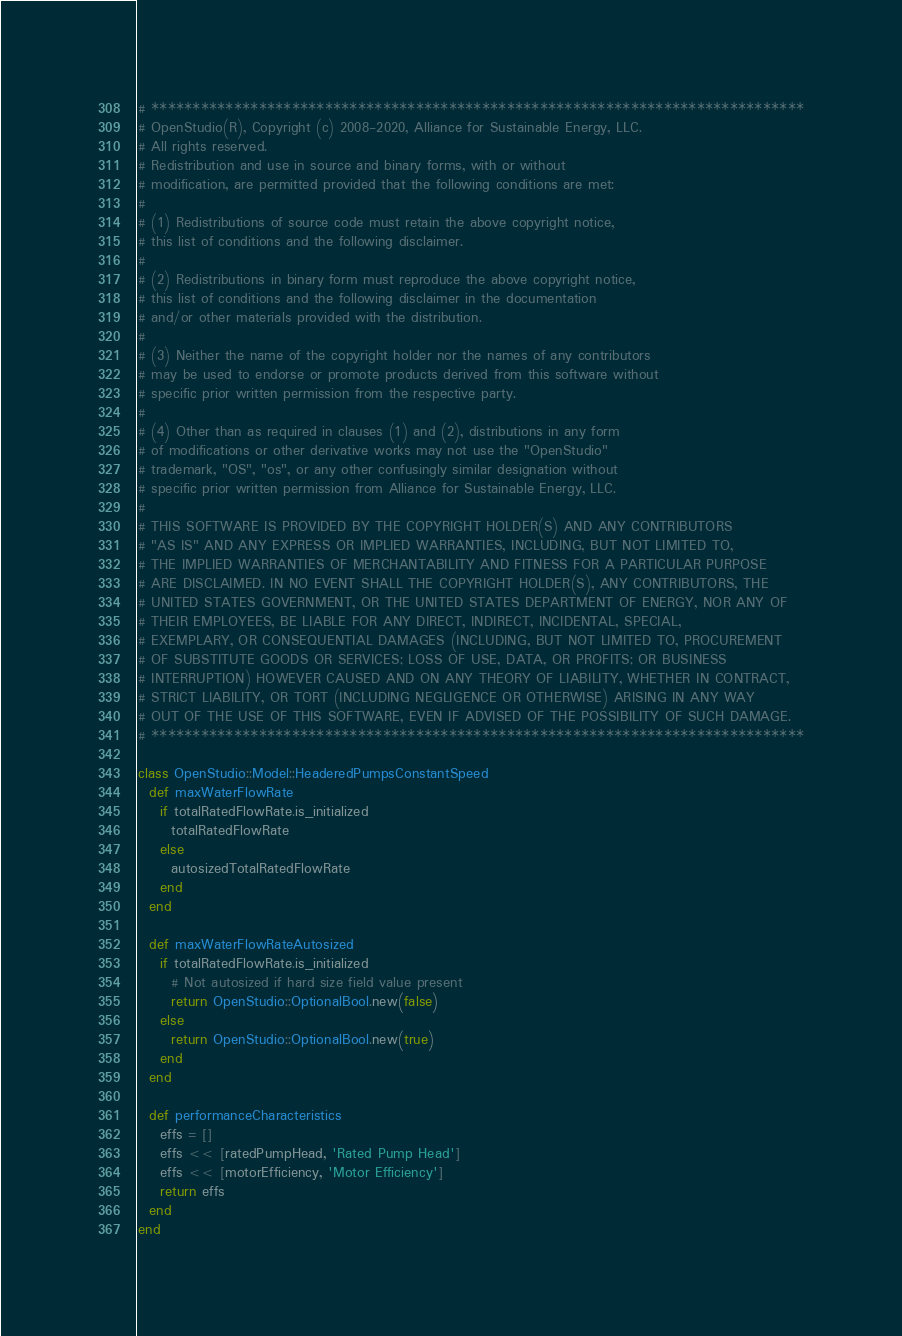<code> <loc_0><loc_0><loc_500><loc_500><_Ruby_># *******************************************************************************
# OpenStudio(R), Copyright (c) 2008-2020, Alliance for Sustainable Energy, LLC.
# All rights reserved.
# Redistribution and use in source and binary forms, with or without
# modification, are permitted provided that the following conditions are met:
#
# (1) Redistributions of source code must retain the above copyright notice,
# this list of conditions and the following disclaimer.
#
# (2) Redistributions in binary form must reproduce the above copyright notice,
# this list of conditions and the following disclaimer in the documentation
# and/or other materials provided with the distribution.
#
# (3) Neither the name of the copyright holder nor the names of any contributors
# may be used to endorse or promote products derived from this software without
# specific prior written permission from the respective party.
#
# (4) Other than as required in clauses (1) and (2), distributions in any form
# of modifications or other derivative works may not use the "OpenStudio"
# trademark, "OS", "os", or any other confusingly similar designation without
# specific prior written permission from Alliance for Sustainable Energy, LLC.
#
# THIS SOFTWARE IS PROVIDED BY THE COPYRIGHT HOLDER(S) AND ANY CONTRIBUTORS
# "AS IS" AND ANY EXPRESS OR IMPLIED WARRANTIES, INCLUDING, BUT NOT LIMITED TO,
# THE IMPLIED WARRANTIES OF MERCHANTABILITY AND FITNESS FOR A PARTICULAR PURPOSE
# ARE DISCLAIMED. IN NO EVENT SHALL THE COPYRIGHT HOLDER(S), ANY CONTRIBUTORS, THE
# UNITED STATES GOVERNMENT, OR THE UNITED STATES DEPARTMENT OF ENERGY, NOR ANY OF
# THEIR EMPLOYEES, BE LIABLE FOR ANY DIRECT, INDIRECT, INCIDENTAL, SPECIAL,
# EXEMPLARY, OR CONSEQUENTIAL DAMAGES (INCLUDING, BUT NOT LIMITED TO, PROCUREMENT
# OF SUBSTITUTE GOODS OR SERVICES; LOSS OF USE, DATA, OR PROFITS; OR BUSINESS
# INTERRUPTION) HOWEVER CAUSED AND ON ANY THEORY OF LIABILITY, WHETHER IN CONTRACT,
# STRICT LIABILITY, OR TORT (INCLUDING NEGLIGENCE OR OTHERWISE) ARISING IN ANY WAY
# OUT OF THE USE OF THIS SOFTWARE, EVEN IF ADVISED OF THE POSSIBILITY OF SUCH DAMAGE.
# *******************************************************************************

class OpenStudio::Model::HeaderedPumpsConstantSpeed
  def maxWaterFlowRate
    if totalRatedFlowRate.is_initialized
      totalRatedFlowRate
    else
      autosizedTotalRatedFlowRate
    end
  end

  def maxWaterFlowRateAutosized
    if totalRatedFlowRate.is_initialized
      # Not autosized if hard size field value present
      return OpenStudio::OptionalBool.new(false)
    else
      return OpenStudio::OptionalBool.new(true)
    end
  end

  def performanceCharacteristics
    effs = []
    effs << [ratedPumpHead, 'Rated Pump Head']
    effs << [motorEfficiency, 'Motor Efficiency']
    return effs
  end
end
</code> 